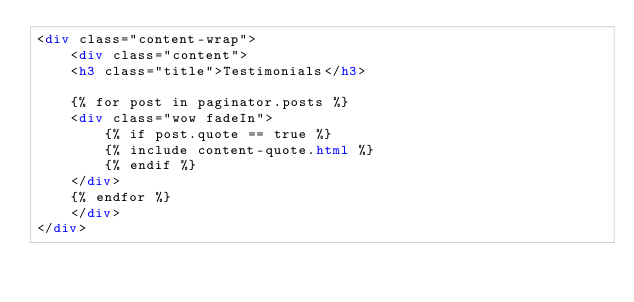<code> <loc_0><loc_0><loc_500><loc_500><_HTML_><div class="content-wrap">
    <div class="content">
    <h3 class="title">Testimonials</h3>

    {% for post in paginator.posts %}
    <div class="wow fadeIn">
        {% if post.quote == true %}
        {% include content-quote.html %}
        {% endif %}
    </div>
    {% endfor %}
    </div>
</div>
</code> 